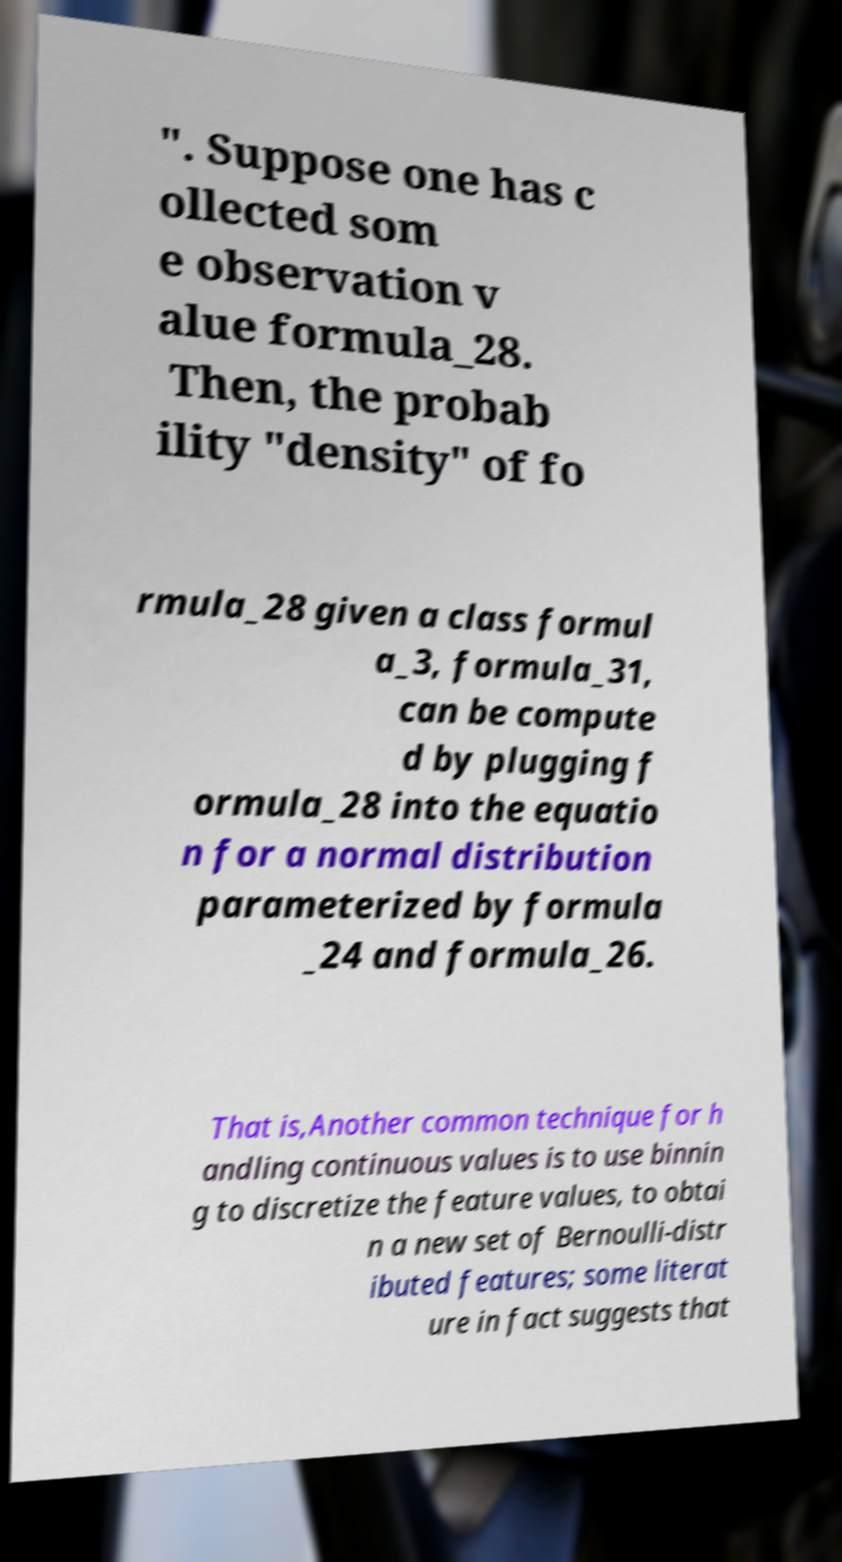Can you accurately transcribe the text from the provided image for me? ". Suppose one has c ollected som e observation v alue formula_28. Then, the probab ility "density" of fo rmula_28 given a class formul a_3, formula_31, can be compute d by plugging f ormula_28 into the equatio n for a normal distribution parameterized by formula _24 and formula_26. That is,Another common technique for h andling continuous values is to use binnin g to discretize the feature values, to obtai n a new set of Bernoulli-distr ibuted features; some literat ure in fact suggests that 